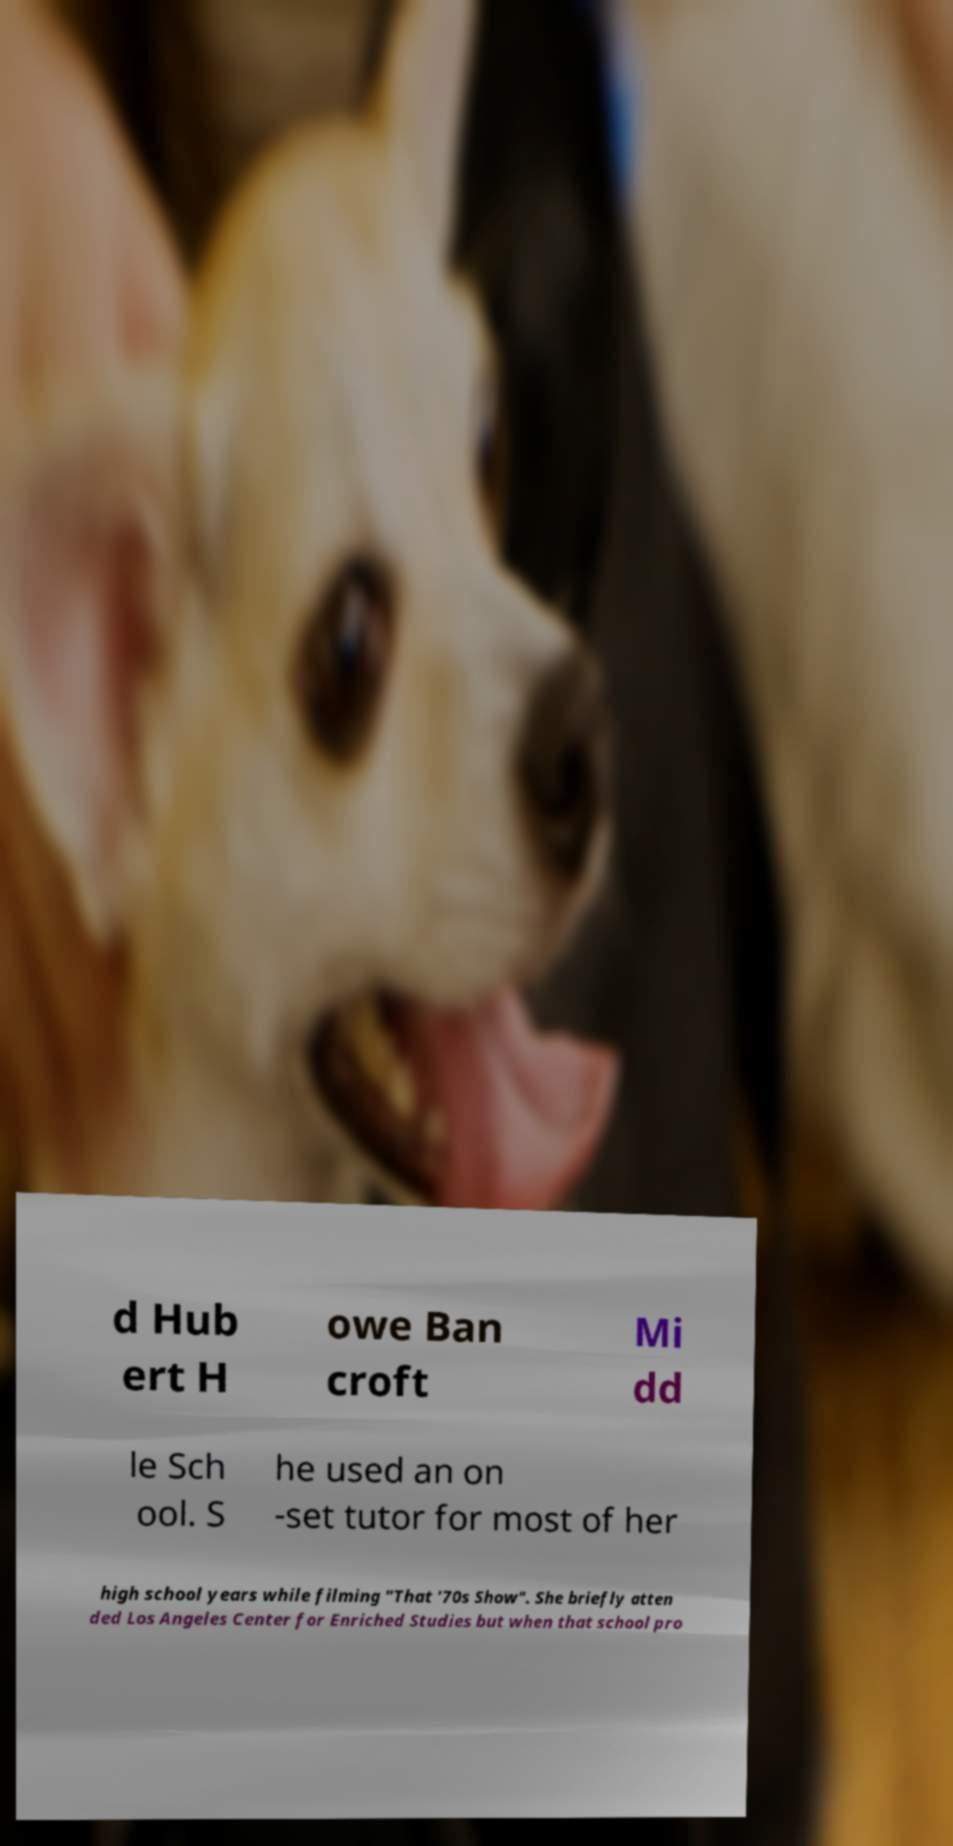There's text embedded in this image that I need extracted. Can you transcribe it verbatim? d Hub ert H owe Ban croft Mi dd le Sch ool. S he used an on -set tutor for most of her high school years while filming "That '70s Show". She briefly atten ded Los Angeles Center for Enriched Studies but when that school pro 